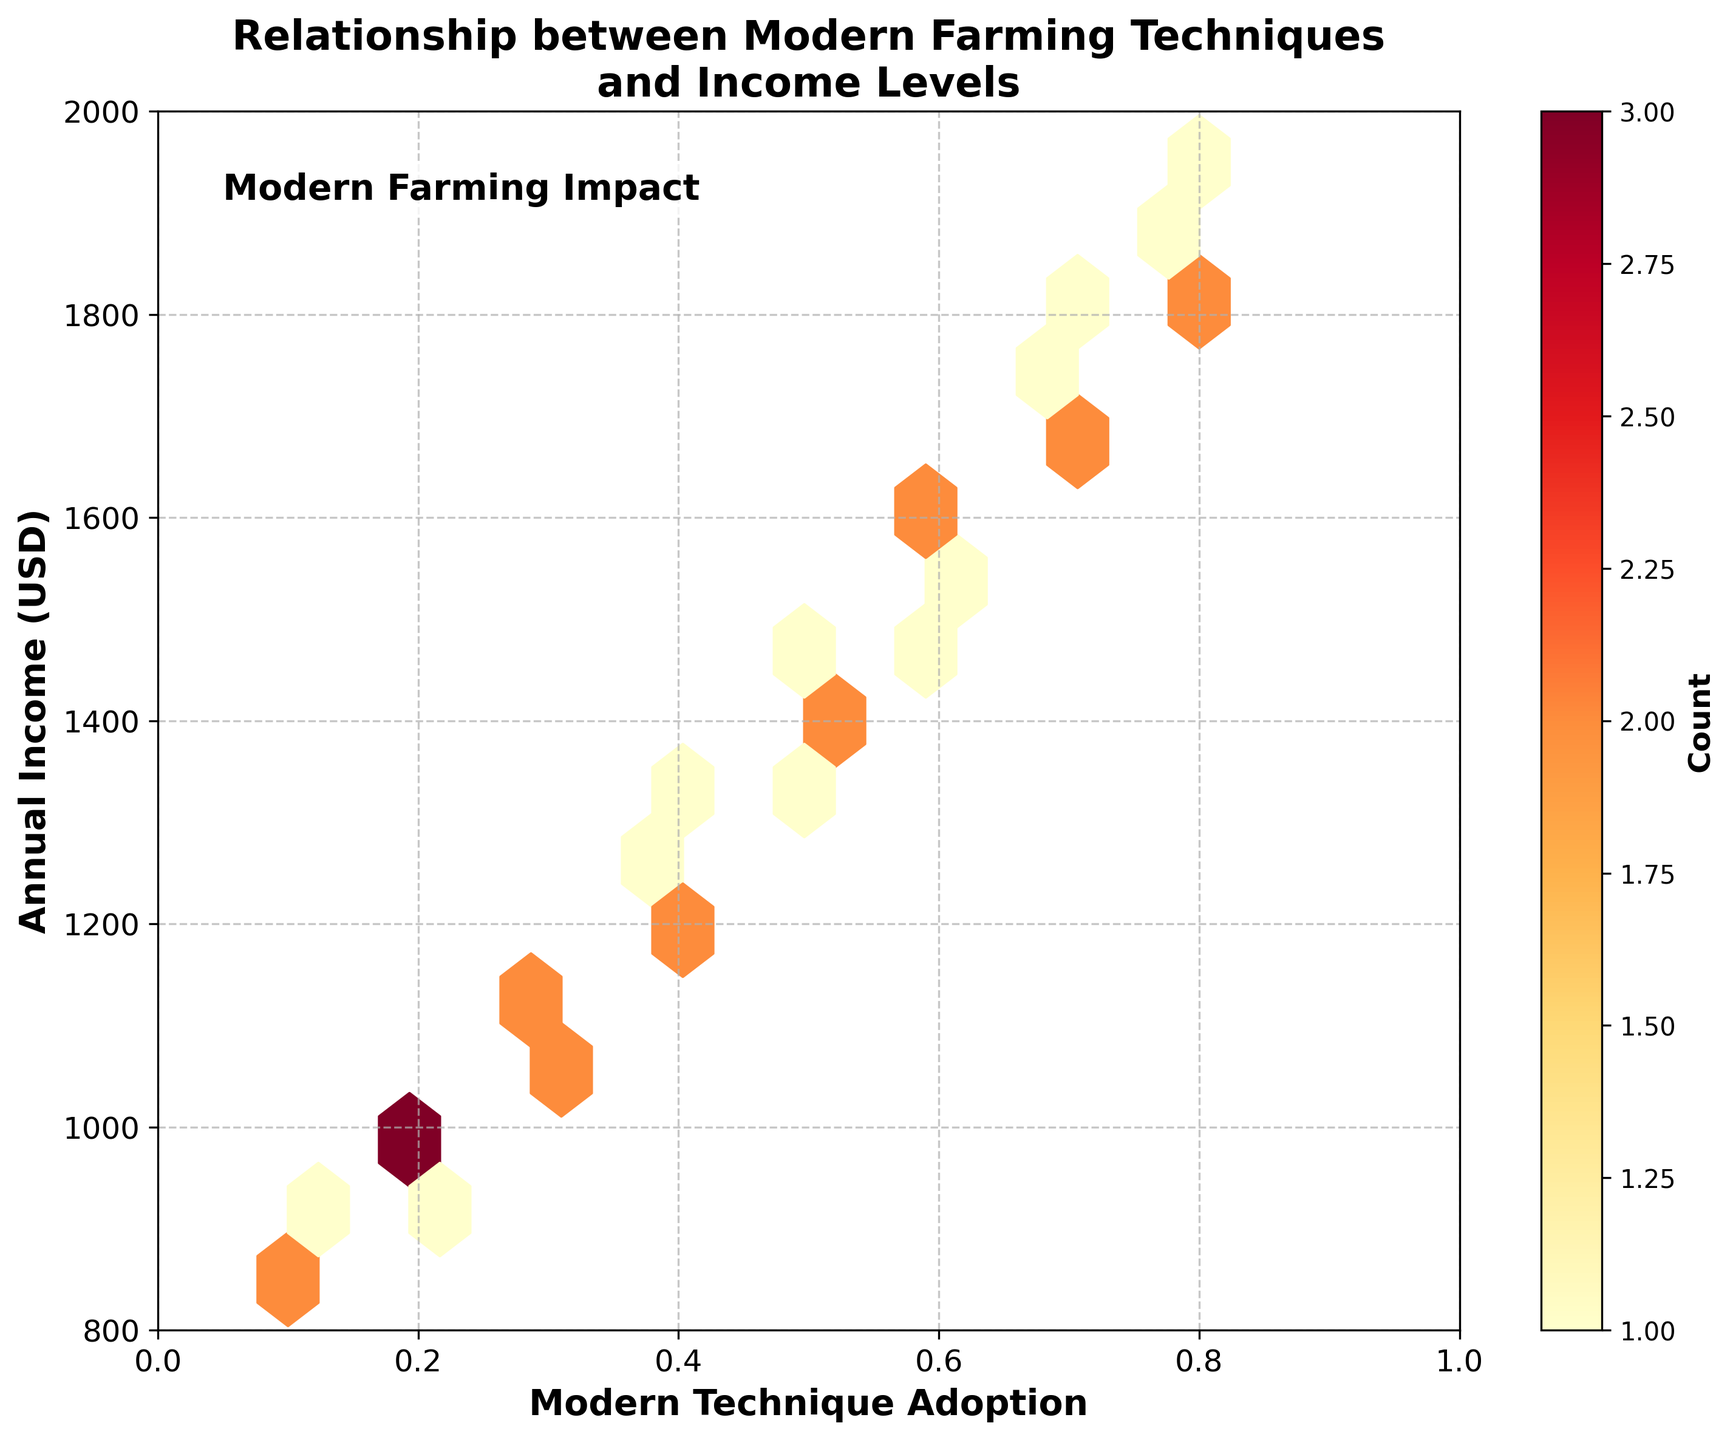What does the title of the figure indicate? The title of the figure indicates the relationship being analyzed, which is between the adoption of modern farming techniques and the income levels among rural farmers.
Answer: Relationship between Modern Farming Techniques and Income Levels What do the color intensities in the plot represent? The color intensities in the hexagons represent the count or density of data points that fall within a particular area; the darker the color, the higher the number of data points.
Answer: Count of data points What are the axes labels and what do they signify? The x-axis is labeled "Modern Technique Adoption," representing the extent to which farmers have adopted new techniques. The y-axis is labeled "Annual Income (USD)," representing the annual income of the farmers in US dollars.
Answer: Modern Technique Adoption and Annual Income (USD) How does the count distribution appear across different values of modern technique adoption? The count distribution shows higher densities (darker hexagons) in mid-to-high ranges of technique adoption (0.4 to 0.8 on the x-axis), indicating more data points/clusters in these areas.
Answer: Higher densities in 0.4 to 0.8 Between modern technique adoption levels of 0.4 and 0.8, how does the annual income change as the adoption increases? As the adoption of modern techniques increases from 0.4 to 0.8, the annual income generally increases, showing a positive correlation between these variables.
Answer: Income increases What is the income range for farmers who have adopted modern techniques at the level of 0.6? At the adoption level of 0.6, the annual income ranges roughly from $1500 to $1600, as shown by the vertical spread of the hexagons around this x-value.
Answer: $1500 to $1600 Are there any farmers with a modern technique adoption level at 0.1 or lower, and how does their income compare to others? Yes, farmers with a modern technique adoption level of 0.1 have relatively lower annual incomes, ranging from $850 to $900, compared to those with higher adoption levels.
Answer: $850 to $900 Which range of income levels shows higher frequency or density of data points, according to the hexbin plot? The income levels between $1200 and $1600 show higher density, as indicated by the darker hexagons, suggesting more farmers fall within this income range.
Answer: $1200 to $1600 Is there any visible trend in the relationship between the adoption of modern techniques and annual income? The figure shows a clear positive trend where higher adoption levels of modern farming techniques are associated with higher annual incomes.
Answer: Positive trend For farmers earning around $1100 annually, what is the approximate range of modern technique adoption levels? Farmers earning around $1100 annually have adopted modern techniques at levels ranging approximately between 0.2 and 0.3.
Answer: 0.2 to 0.3 